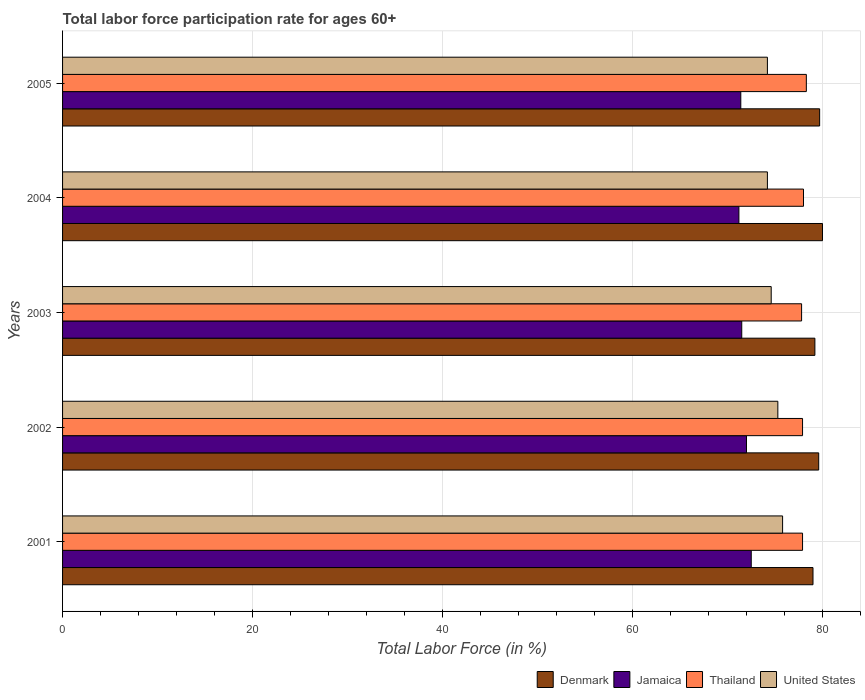How many different coloured bars are there?
Offer a very short reply. 4. How many groups of bars are there?
Offer a very short reply. 5. What is the label of the 3rd group of bars from the top?
Your answer should be compact. 2003. In how many cases, is the number of bars for a given year not equal to the number of legend labels?
Keep it short and to the point. 0. What is the labor force participation rate in Jamaica in 2004?
Make the answer very short. 71.2. Across all years, what is the maximum labor force participation rate in Thailand?
Make the answer very short. 78.3. Across all years, what is the minimum labor force participation rate in United States?
Provide a succinct answer. 74.2. In which year was the labor force participation rate in Denmark minimum?
Ensure brevity in your answer.  2001. What is the total labor force participation rate in Denmark in the graph?
Ensure brevity in your answer.  397.5. What is the difference between the labor force participation rate in Thailand in 2001 and the labor force participation rate in Denmark in 2002?
Your answer should be very brief. -1.7. What is the average labor force participation rate in Thailand per year?
Your response must be concise. 77.98. In the year 2001, what is the difference between the labor force participation rate in Denmark and labor force participation rate in Thailand?
Your answer should be compact. 1.1. In how many years, is the labor force participation rate in Denmark greater than 4 %?
Provide a succinct answer. 5. What is the ratio of the labor force participation rate in United States in 2002 to that in 2004?
Offer a terse response. 1.01. Is the labor force participation rate in Denmark in 2001 less than that in 2004?
Your response must be concise. Yes. Is the difference between the labor force participation rate in Denmark in 2001 and 2005 greater than the difference between the labor force participation rate in Thailand in 2001 and 2005?
Provide a short and direct response. No. What is the difference between the highest and the second highest labor force participation rate in Denmark?
Ensure brevity in your answer.  0.3. What is the difference between the highest and the lowest labor force participation rate in Denmark?
Offer a very short reply. 1. In how many years, is the labor force participation rate in Jamaica greater than the average labor force participation rate in Jamaica taken over all years?
Give a very brief answer. 2. Is it the case that in every year, the sum of the labor force participation rate in Jamaica and labor force participation rate in Denmark is greater than the sum of labor force participation rate in United States and labor force participation rate in Thailand?
Your response must be concise. No. What does the 3rd bar from the bottom in 2001 represents?
Offer a very short reply. Thailand. Is it the case that in every year, the sum of the labor force participation rate in Thailand and labor force participation rate in Jamaica is greater than the labor force participation rate in United States?
Provide a succinct answer. Yes. How many bars are there?
Ensure brevity in your answer.  20. Are all the bars in the graph horizontal?
Your answer should be very brief. Yes. What is the difference between two consecutive major ticks on the X-axis?
Give a very brief answer. 20. Does the graph contain any zero values?
Make the answer very short. No. Where does the legend appear in the graph?
Keep it short and to the point. Bottom right. How are the legend labels stacked?
Your response must be concise. Horizontal. What is the title of the graph?
Your answer should be very brief. Total labor force participation rate for ages 60+. What is the label or title of the X-axis?
Provide a succinct answer. Total Labor Force (in %). What is the Total Labor Force (in %) in Denmark in 2001?
Give a very brief answer. 79. What is the Total Labor Force (in %) of Jamaica in 2001?
Ensure brevity in your answer.  72.5. What is the Total Labor Force (in %) in Thailand in 2001?
Your answer should be compact. 77.9. What is the Total Labor Force (in %) of United States in 2001?
Your answer should be compact. 75.8. What is the Total Labor Force (in %) in Denmark in 2002?
Your answer should be very brief. 79.6. What is the Total Labor Force (in %) in Thailand in 2002?
Your answer should be very brief. 77.9. What is the Total Labor Force (in %) of United States in 2002?
Your answer should be compact. 75.3. What is the Total Labor Force (in %) of Denmark in 2003?
Provide a succinct answer. 79.2. What is the Total Labor Force (in %) in Jamaica in 2003?
Give a very brief answer. 71.5. What is the Total Labor Force (in %) in Thailand in 2003?
Offer a terse response. 77.8. What is the Total Labor Force (in %) of United States in 2003?
Provide a succinct answer. 74.6. What is the Total Labor Force (in %) in Jamaica in 2004?
Your answer should be compact. 71.2. What is the Total Labor Force (in %) in Thailand in 2004?
Make the answer very short. 78. What is the Total Labor Force (in %) in United States in 2004?
Give a very brief answer. 74.2. What is the Total Labor Force (in %) in Denmark in 2005?
Your response must be concise. 79.7. What is the Total Labor Force (in %) in Jamaica in 2005?
Ensure brevity in your answer.  71.4. What is the Total Labor Force (in %) of Thailand in 2005?
Your answer should be very brief. 78.3. What is the Total Labor Force (in %) of United States in 2005?
Provide a succinct answer. 74.2. Across all years, what is the maximum Total Labor Force (in %) of Denmark?
Offer a terse response. 80. Across all years, what is the maximum Total Labor Force (in %) of Jamaica?
Your answer should be compact. 72.5. Across all years, what is the maximum Total Labor Force (in %) of Thailand?
Your answer should be very brief. 78.3. Across all years, what is the maximum Total Labor Force (in %) in United States?
Your response must be concise. 75.8. Across all years, what is the minimum Total Labor Force (in %) of Denmark?
Make the answer very short. 79. Across all years, what is the minimum Total Labor Force (in %) of Jamaica?
Give a very brief answer. 71.2. Across all years, what is the minimum Total Labor Force (in %) of Thailand?
Your response must be concise. 77.8. Across all years, what is the minimum Total Labor Force (in %) in United States?
Your answer should be very brief. 74.2. What is the total Total Labor Force (in %) in Denmark in the graph?
Provide a short and direct response. 397.5. What is the total Total Labor Force (in %) of Jamaica in the graph?
Keep it short and to the point. 358.6. What is the total Total Labor Force (in %) in Thailand in the graph?
Give a very brief answer. 389.9. What is the total Total Labor Force (in %) of United States in the graph?
Provide a short and direct response. 374.1. What is the difference between the Total Labor Force (in %) of Thailand in 2001 and that in 2002?
Give a very brief answer. 0. What is the difference between the Total Labor Force (in %) in United States in 2001 and that in 2002?
Give a very brief answer. 0.5. What is the difference between the Total Labor Force (in %) of Thailand in 2001 and that in 2003?
Provide a short and direct response. 0.1. What is the difference between the Total Labor Force (in %) in Jamaica in 2001 and that in 2004?
Your answer should be very brief. 1.3. What is the difference between the Total Labor Force (in %) in United States in 2001 and that in 2004?
Provide a short and direct response. 1.6. What is the difference between the Total Labor Force (in %) of Denmark in 2001 and that in 2005?
Give a very brief answer. -0.7. What is the difference between the Total Labor Force (in %) of Thailand in 2002 and that in 2003?
Provide a succinct answer. 0.1. What is the difference between the Total Labor Force (in %) of United States in 2002 and that in 2003?
Ensure brevity in your answer.  0.7. What is the difference between the Total Labor Force (in %) of Denmark in 2002 and that in 2004?
Provide a short and direct response. -0.4. What is the difference between the Total Labor Force (in %) in Jamaica in 2002 and that in 2004?
Offer a very short reply. 0.8. What is the difference between the Total Labor Force (in %) of United States in 2002 and that in 2004?
Provide a short and direct response. 1.1. What is the difference between the Total Labor Force (in %) in Jamaica in 2002 and that in 2005?
Your answer should be compact. 0.6. What is the difference between the Total Labor Force (in %) in Thailand in 2002 and that in 2005?
Keep it short and to the point. -0.4. What is the difference between the Total Labor Force (in %) of Jamaica in 2003 and that in 2004?
Your answer should be compact. 0.3. What is the difference between the Total Labor Force (in %) in Thailand in 2003 and that in 2004?
Provide a succinct answer. -0.2. What is the difference between the Total Labor Force (in %) in Thailand in 2003 and that in 2005?
Your response must be concise. -0.5. What is the difference between the Total Labor Force (in %) of United States in 2003 and that in 2005?
Your answer should be very brief. 0.4. What is the difference between the Total Labor Force (in %) in Jamaica in 2004 and that in 2005?
Make the answer very short. -0.2. What is the difference between the Total Labor Force (in %) in Denmark in 2001 and the Total Labor Force (in %) in Jamaica in 2002?
Offer a terse response. 7. What is the difference between the Total Labor Force (in %) of Denmark in 2001 and the Total Labor Force (in %) of United States in 2002?
Offer a terse response. 3.7. What is the difference between the Total Labor Force (in %) of Jamaica in 2001 and the Total Labor Force (in %) of United States in 2003?
Make the answer very short. -2.1. What is the difference between the Total Labor Force (in %) of Denmark in 2001 and the Total Labor Force (in %) of United States in 2004?
Your response must be concise. 4.8. What is the difference between the Total Labor Force (in %) in Jamaica in 2001 and the Total Labor Force (in %) in Thailand in 2004?
Ensure brevity in your answer.  -5.5. What is the difference between the Total Labor Force (in %) of Denmark in 2001 and the Total Labor Force (in %) of Jamaica in 2005?
Provide a succinct answer. 7.6. What is the difference between the Total Labor Force (in %) of Denmark in 2001 and the Total Labor Force (in %) of United States in 2005?
Ensure brevity in your answer.  4.8. What is the difference between the Total Labor Force (in %) of Jamaica in 2001 and the Total Labor Force (in %) of United States in 2005?
Give a very brief answer. -1.7. What is the difference between the Total Labor Force (in %) of Denmark in 2002 and the Total Labor Force (in %) of Thailand in 2003?
Provide a succinct answer. 1.8. What is the difference between the Total Labor Force (in %) in Denmark in 2002 and the Total Labor Force (in %) in United States in 2003?
Your response must be concise. 5. What is the difference between the Total Labor Force (in %) of Jamaica in 2002 and the Total Labor Force (in %) of Thailand in 2003?
Give a very brief answer. -5.8. What is the difference between the Total Labor Force (in %) of Jamaica in 2002 and the Total Labor Force (in %) of United States in 2003?
Give a very brief answer. -2.6. What is the difference between the Total Labor Force (in %) in Thailand in 2002 and the Total Labor Force (in %) in United States in 2003?
Make the answer very short. 3.3. What is the difference between the Total Labor Force (in %) in Denmark in 2002 and the Total Labor Force (in %) in Thailand in 2004?
Give a very brief answer. 1.6. What is the difference between the Total Labor Force (in %) in Denmark in 2002 and the Total Labor Force (in %) in United States in 2004?
Offer a terse response. 5.4. What is the difference between the Total Labor Force (in %) in Jamaica in 2002 and the Total Labor Force (in %) in United States in 2004?
Your answer should be very brief. -2.2. What is the difference between the Total Labor Force (in %) in Denmark in 2002 and the Total Labor Force (in %) in Thailand in 2005?
Your answer should be very brief. 1.3. What is the difference between the Total Labor Force (in %) of Denmark in 2002 and the Total Labor Force (in %) of United States in 2005?
Ensure brevity in your answer.  5.4. What is the difference between the Total Labor Force (in %) of Jamaica in 2002 and the Total Labor Force (in %) of United States in 2005?
Keep it short and to the point. -2.2. What is the difference between the Total Labor Force (in %) in Denmark in 2003 and the Total Labor Force (in %) in Jamaica in 2004?
Offer a very short reply. 8. What is the difference between the Total Labor Force (in %) of Denmark in 2003 and the Total Labor Force (in %) of Thailand in 2004?
Provide a succinct answer. 1.2. What is the difference between the Total Labor Force (in %) of Denmark in 2003 and the Total Labor Force (in %) of United States in 2004?
Your answer should be compact. 5. What is the difference between the Total Labor Force (in %) in Jamaica in 2003 and the Total Labor Force (in %) in United States in 2004?
Offer a very short reply. -2.7. What is the difference between the Total Labor Force (in %) of Denmark in 2003 and the Total Labor Force (in %) of Thailand in 2005?
Offer a terse response. 0.9. What is the difference between the Total Labor Force (in %) of Denmark in 2003 and the Total Labor Force (in %) of United States in 2005?
Your answer should be compact. 5. What is the difference between the Total Labor Force (in %) in Denmark in 2004 and the Total Labor Force (in %) in Jamaica in 2005?
Ensure brevity in your answer.  8.6. What is the difference between the Total Labor Force (in %) in Jamaica in 2004 and the Total Labor Force (in %) in Thailand in 2005?
Offer a terse response. -7.1. What is the average Total Labor Force (in %) in Denmark per year?
Your answer should be compact. 79.5. What is the average Total Labor Force (in %) of Jamaica per year?
Provide a short and direct response. 71.72. What is the average Total Labor Force (in %) of Thailand per year?
Offer a very short reply. 77.98. What is the average Total Labor Force (in %) of United States per year?
Provide a succinct answer. 74.82. In the year 2001, what is the difference between the Total Labor Force (in %) in Denmark and Total Labor Force (in %) in Thailand?
Offer a very short reply. 1.1. In the year 2001, what is the difference between the Total Labor Force (in %) in Denmark and Total Labor Force (in %) in United States?
Your answer should be very brief. 3.2. In the year 2002, what is the difference between the Total Labor Force (in %) of Denmark and Total Labor Force (in %) of United States?
Your answer should be compact. 4.3. In the year 2002, what is the difference between the Total Labor Force (in %) of Thailand and Total Labor Force (in %) of United States?
Keep it short and to the point. 2.6. In the year 2003, what is the difference between the Total Labor Force (in %) in Denmark and Total Labor Force (in %) in Jamaica?
Give a very brief answer. 7.7. In the year 2003, what is the difference between the Total Labor Force (in %) in Jamaica and Total Labor Force (in %) in Thailand?
Make the answer very short. -6.3. In the year 2003, what is the difference between the Total Labor Force (in %) of Thailand and Total Labor Force (in %) of United States?
Your response must be concise. 3.2. In the year 2004, what is the difference between the Total Labor Force (in %) in Denmark and Total Labor Force (in %) in Jamaica?
Keep it short and to the point. 8.8. In the year 2004, what is the difference between the Total Labor Force (in %) of Denmark and Total Labor Force (in %) of United States?
Keep it short and to the point. 5.8. In the year 2004, what is the difference between the Total Labor Force (in %) of Jamaica and Total Labor Force (in %) of Thailand?
Your answer should be very brief. -6.8. In the year 2004, what is the difference between the Total Labor Force (in %) in Thailand and Total Labor Force (in %) in United States?
Your response must be concise. 3.8. In the year 2005, what is the difference between the Total Labor Force (in %) of Denmark and Total Labor Force (in %) of Thailand?
Keep it short and to the point. 1.4. In the year 2005, what is the difference between the Total Labor Force (in %) of Jamaica and Total Labor Force (in %) of Thailand?
Offer a terse response. -6.9. In the year 2005, what is the difference between the Total Labor Force (in %) in Jamaica and Total Labor Force (in %) in United States?
Offer a very short reply. -2.8. In the year 2005, what is the difference between the Total Labor Force (in %) in Thailand and Total Labor Force (in %) in United States?
Give a very brief answer. 4.1. What is the ratio of the Total Labor Force (in %) in Denmark in 2001 to that in 2002?
Your answer should be very brief. 0.99. What is the ratio of the Total Labor Force (in %) of Jamaica in 2001 to that in 2002?
Ensure brevity in your answer.  1.01. What is the ratio of the Total Labor Force (in %) of United States in 2001 to that in 2002?
Your answer should be very brief. 1.01. What is the ratio of the Total Labor Force (in %) in Denmark in 2001 to that in 2003?
Your answer should be compact. 1. What is the ratio of the Total Labor Force (in %) in Jamaica in 2001 to that in 2003?
Your answer should be compact. 1.01. What is the ratio of the Total Labor Force (in %) in United States in 2001 to that in 2003?
Keep it short and to the point. 1.02. What is the ratio of the Total Labor Force (in %) in Denmark in 2001 to that in 2004?
Give a very brief answer. 0.99. What is the ratio of the Total Labor Force (in %) of Jamaica in 2001 to that in 2004?
Your answer should be very brief. 1.02. What is the ratio of the Total Labor Force (in %) of United States in 2001 to that in 2004?
Your answer should be very brief. 1.02. What is the ratio of the Total Labor Force (in %) of Jamaica in 2001 to that in 2005?
Your answer should be compact. 1.02. What is the ratio of the Total Labor Force (in %) of Thailand in 2001 to that in 2005?
Provide a short and direct response. 0.99. What is the ratio of the Total Labor Force (in %) in United States in 2001 to that in 2005?
Your response must be concise. 1.02. What is the ratio of the Total Labor Force (in %) in Denmark in 2002 to that in 2003?
Provide a succinct answer. 1.01. What is the ratio of the Total Labor Force (in %) in United States in 2002 to that in 2003?
Your answer should be compact. 1.01. What is the ratio of the Total Labor Force (in %) of Jamaica in 2002 to that in 2004?
Make the answer very short. 1.01. What is the ratio of the Total Labor Force (in %) of Thailand in 2002 to that in 2004?
Make the answer very short. 1. What is the ratio of the Total Labor Force (in %) of United States in 2002 to that in 2004?
Your response must be concise. 1.01. What is the ratio of the Total Labor Force (in %) of Denmark in 2002 to that in 2005?
Provide a short and direct response. 1. What is the ratio of the Total Labor Force (in %) in Jamaica in 2002 to that in 2005?
Your answer should be compact. 1.01. What is the ratio of the Total Labor Force (in %) in United States in 2002 to that in 2005?
Ensure brevity in your answer.  1.01. What is the ratio of the Total Labor Force (in %) in Denmark in 2003 to that in 2004?
Keep it short and to the point. 0.99. What is the ratio of the Total Labor Force (in %) of United States in 2003 to that in 2004?
Offer a very short reply. 1.01. What is the ratio of the Total Labor Force (in %) of Denmark in 2003 to that in 2005?
Your response must be concise. 0.99. What is the ratio of the Total Labor Force (in %) in Jamaica in 2003 to that in 2005?
Provide a succinct answer. 1. What is the ratio of the Total Labor Force (in %) of United States in 2003 to that in 2005?
Offer a terse response. 1.01. What is the ratio of the Total Labor Force (in %) of Denmark in 2004 to that in 2005?
Give a very brief answer. 1. What is the difference between the highest and the second highest Total Labor Force (in %) of Jamaica?
Offer a very short reply. 0.5. What is the difference between the highest and the lowest Total Labor Force (in %) of Jamaica?
Offer a very short reply. 1.3. What is the difference between the highest and the lowest Total Labor Force (in %) in United States?
Make the answer very short. 1.6. 